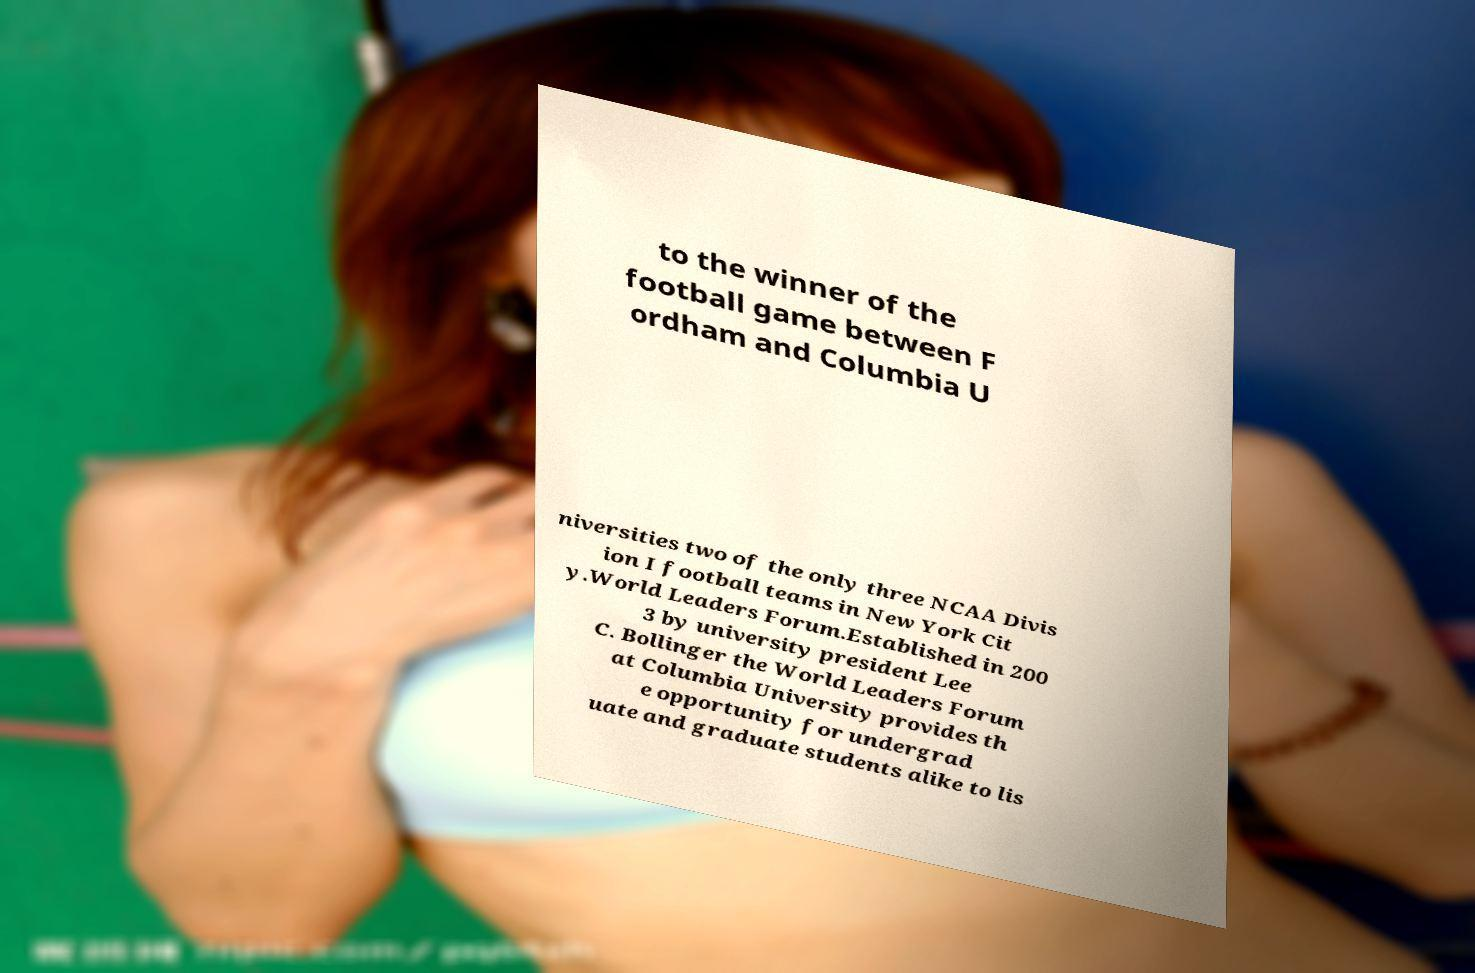What messages or text are displayed in this image? I need them in a readable, typed format. to the winner of the football game between F ordham and Columbia U niversities two of the only three NCAA Divis ion I football teams in New York Cit y.World Leaders Forum.Established in 200 3 by university president Lee C. Bollinger the World Leaders Forum at Columbia University provides th e opportunity for undergrad uate and graduate students alike to lis 